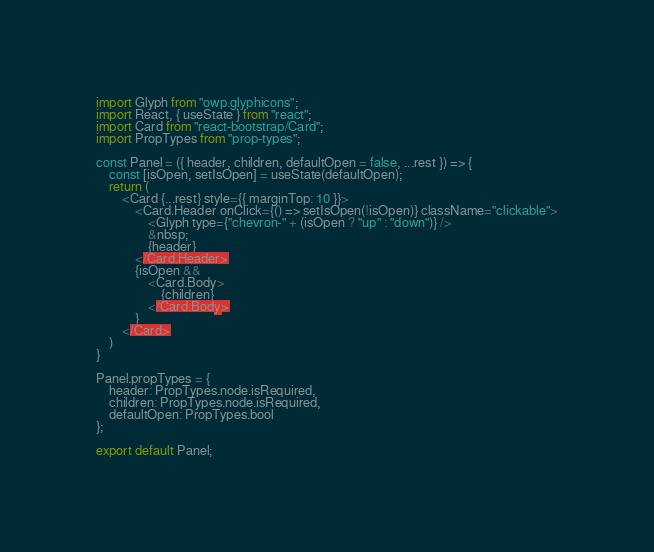Convert code to text. <code><loc_0><loc_0><loc_500><loc_500><_JavaScript_>import Glyph from "owp.glyphicons";
import React, { useState } from "react";
import Card from "react-bootstrap/Card";
import PropTypes from "prop-types";

const Panel = ({ header, children, defaultOpen = false, ...rest }) => {
    const [isOpen, setIsOpen] = useState(defaultOpen);
    return (
        <Card {...rest} style={{ marginTop: 10 }}>
            <Card.Header onClick={() => setIsOpen(!isOpen)} className="clickable">
                <Glyph type={"chevron-" + (isOpen ? "up" : "down")} />
                &nbsp;
                {header}
            </Card.Header>
            {isOpen &&
                <Card.Body>
                    {children}
                </Card.Body>
            }
        </Card>
    )
}

Panel.propTypes = {
    header: PropTypes.node.isRequired,
    children: PropTypes.node.isRequired,
    defaultOpen: PropTypes.bool
};

export default Panel;</code> 